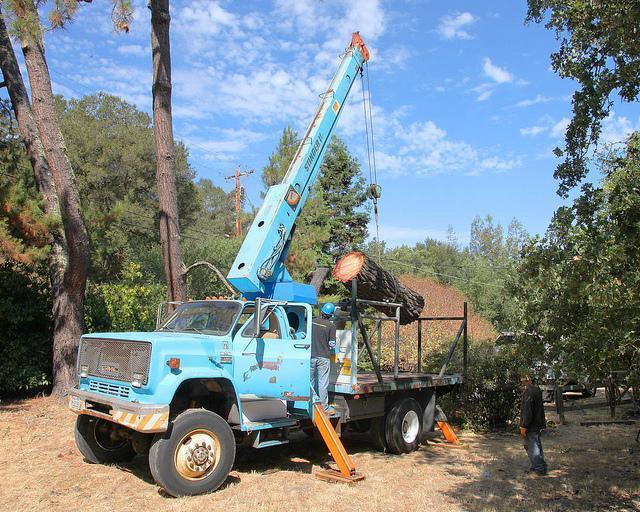How many elephants are standing on two legs?
Give a very brief answer. 0. 